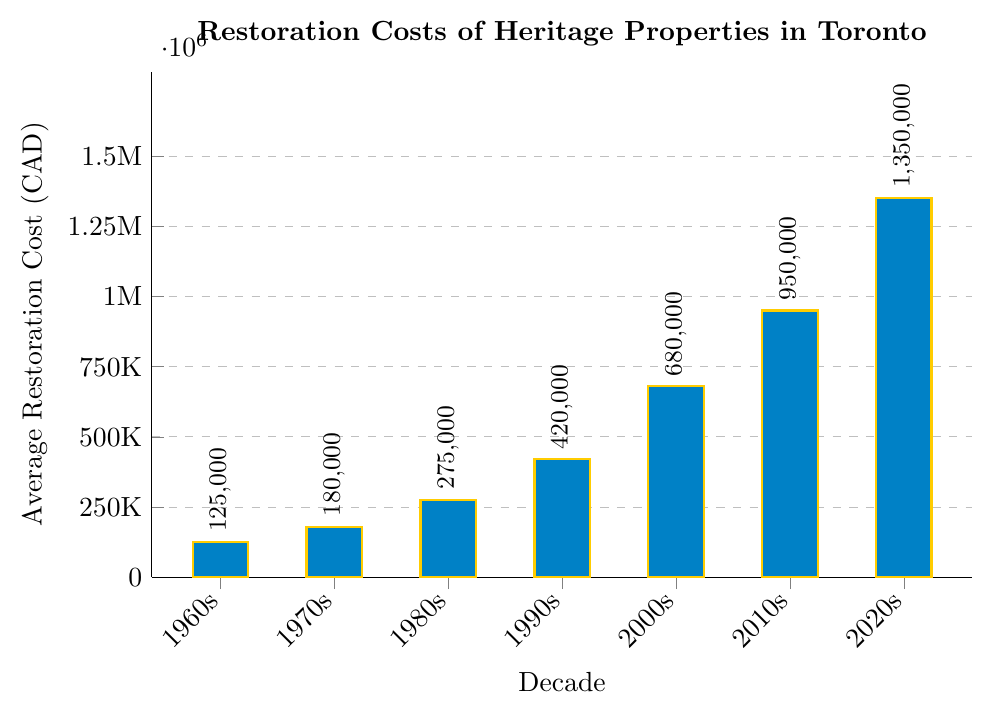What is the average restoration cost of heritage properties in the 1980s? The bar for the 1980s reaches up to 275,000 CAD.
Answer: 275,000 CAD How much more were the restoration costs in the 2020s compared to the 2000s? The bar for the 2020s shows 1,350,000 CAD, and for the 2000s it's 680,000 CAD. The difference is 1,350,000 - 680,000 = 670,000 CAD.
Answer: 670,000 CAD Which decade saw the lowest average restoration cost, and what was it? The bar for the 1960s is the lowest and reaches up to 125,000 CAD.
Answer: 1960s, 125,000 CAD By how much did the average restoration cost increase from the 1990s to the 2010s? The bar for the 1990s is 420,000 CAD, and for the 2010s it's 950,000 CAD. The increase is 950,000 - 420,000 = 530,000 CAD.
Answer: 530,000 CAD What was the average restoration cost in the 2010s? The bar for the 2010s reaches up to 950,000 CAD.
Answer: 950,000 CAD What is the total average restoration cost from the 1960s to the 2020s? Sum the values: 125,000 (1960s) + 180,000 (1970s) + 275,000 (1980s) + 420,000 (1990s) + 680,000 (2000s) + 950,000 (2010s) + 1,350,000 (2020s) = 3,980,000 CAD.
Answer: 3,980,000 CAD Which decades had restoration costs exceeding 500,000 CAD? The bars for the 2000s (680,000 CAD), 2010s (950,000 CAD), and 2020s (1,350,000 CAD) exceed 500,000 CAD.
Answer: 2000s, 2010s, 2020s What is the average increase in restoration costs per decade from the 1960s to the 2020s? Calculate the increase for each decade and then find the average.
1,350,000 (2020s) - 950,000 (2010s) = 400,000
950,000 (2010s) - 680,000 (2000s) = 270,000
680,000 (2000s) - 420,000 (1990s) = 260,000
420,000 (1990s) - 275,000 (1980s) = 145,000
275,000 (1980s) - 180,000 (1970s) = 95,000
180,000 (1970s) - 125,000 (1960s) = 55,000
Sum is 400,000 + 270,000 + 260,000 + 145,000 + 95,000 + 55,000 = 1,225,000.
Average increase is 1,225,000 / 6 = 204,167 CAD.
Answer: 204,167 CAD How much more is the restoration cost in the 2020s compared to the 1960s? The bar for the 2020s shows 1,350,000 CAD, and for the 1960s it's 125,000 CAD. The difference is 1,350,000 - 125,000 = 1,225,000 CAD.
Answer: 1,225,000 CAD 